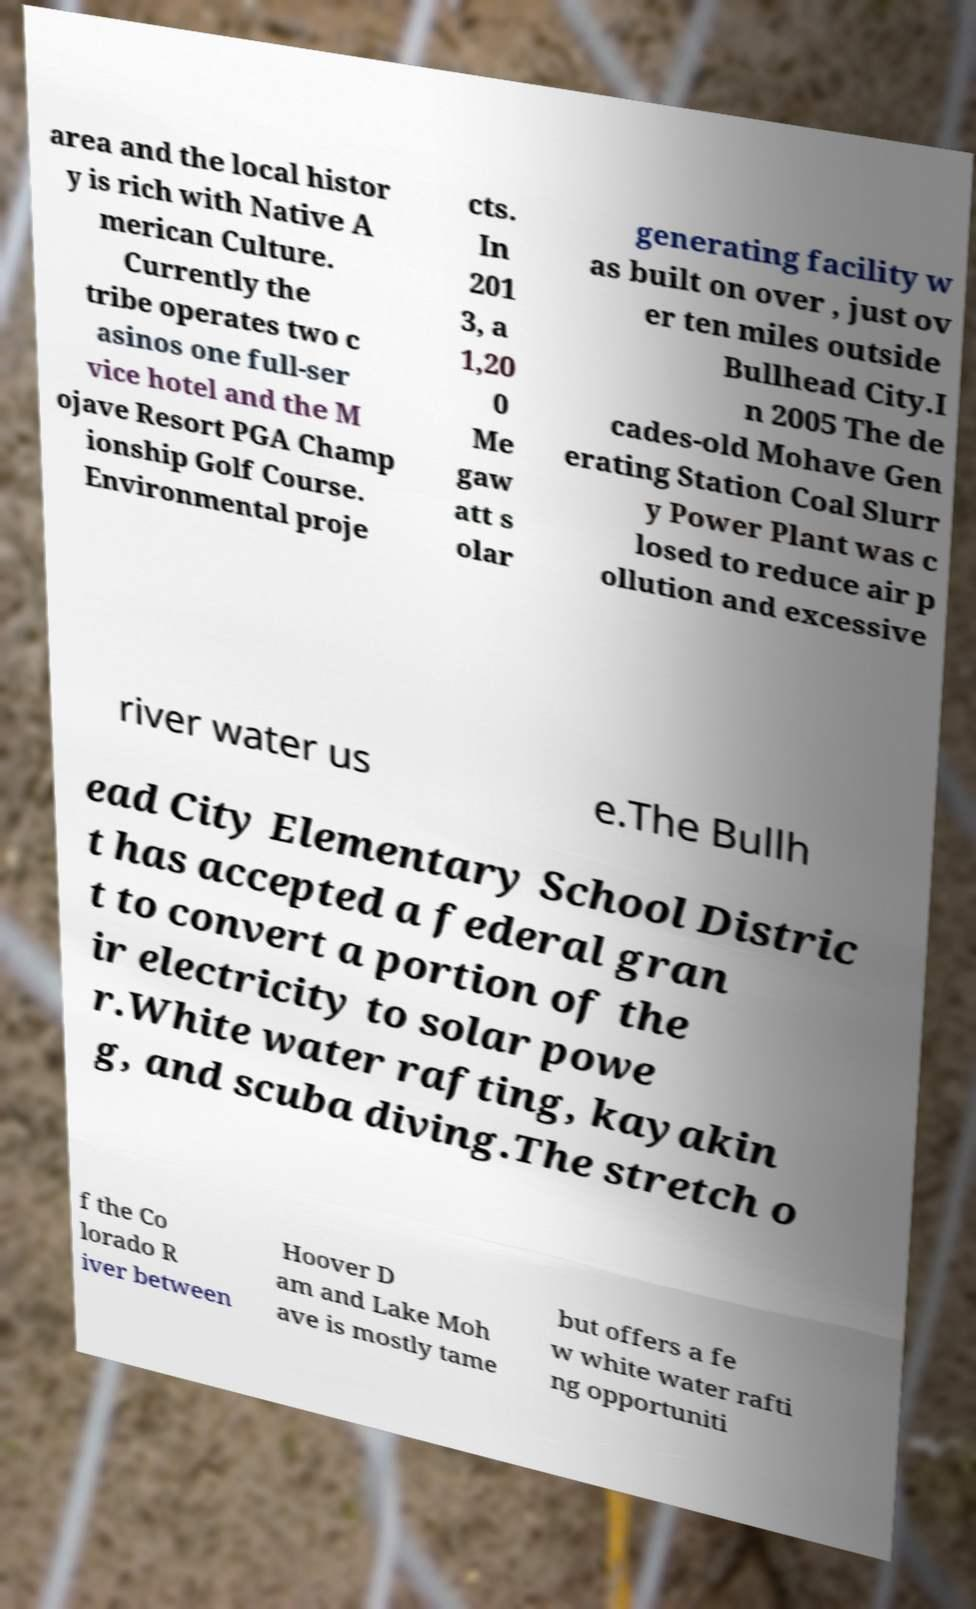Could you assist in decoding the text presented in this image and type it out clearly? area and the local histor y is rich with Native A merican Culture. Currently the tribe operates two c asinos one full-ser vice hotel and the M ojave Resort PGA Champ ionship Golf Course. Environmental proje cts. In 201 3, a 1,20 0 Me gaw att s olar generating facility w as built on over , just ov er ten miles outside Bullhead City.I n 2005 The de cades-old Mohave Gen erating Station Coal Slurr y Power Plant was c losed to reduce air p ollution and excessive river water us e.The Bullh ead City Elementary School Distric t has accepted a federal gran t to convert a portion of the ir electricity to solar powe r.White water rafting, kayakin g, and scuba diving.The stretch o f the Co lorado R iver between Hoover D am and Lake Moh ave is mostly tame but offers a fe w white water rafti ng opportuniti 